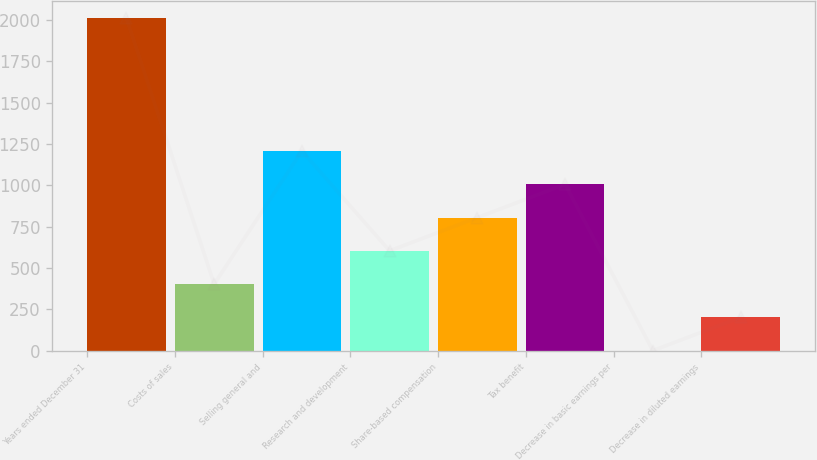Convert chart to OTSL. <chart><loc_0><loc_0><loc_500><loc_500><bar_chart><fcel>Years ended December 31<fcel>Costs of sales<fcel>Selling general and<fcel>Research and development<fcel>Share-based compensation<fcel>Tax benefit<fcel>Decrease in basic earnings per<fcel>Decrease in diluted earnings<nl><fcel>2012<fcel>402.67<fcel>1207.35<fcel>603.84<fcel>805.01<fcel>1006.18<fcel>0.33<fcel>201.5<nl></chart> 